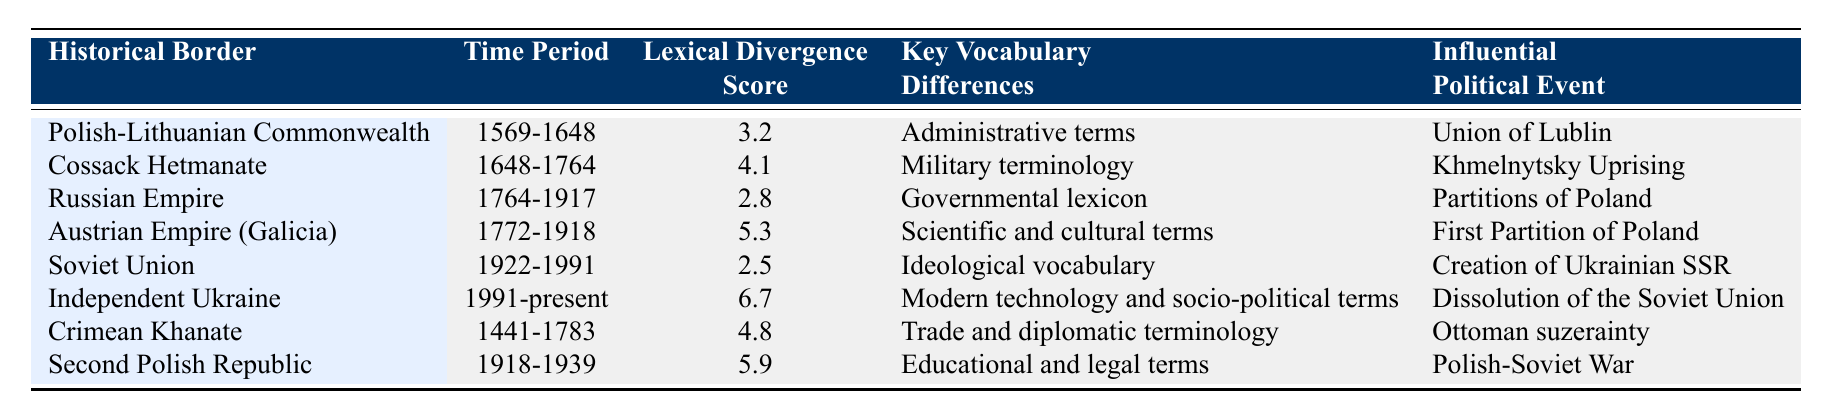What is the lexical divergence score for the Soviet Union? The table lists the lexical divergence score for the Soviet Union under the "Lexical Divergence Score" column, indicating it is 2.5.
Answer: 2.5 Which historical border had the highest lexical divergence score? By comparing the lexical divergence scores listed in the table, the highest score is 6.7, which corresponds to the Independent Ukraine.
Answer: 6.7 True or False: The Cossack Hetmanate period had a higher lexical divergence score than the Russian Empire period. The Cossack Hetmanate score is 4.1, while the Russian Empire score is 2.8. 4.1 is greater than 2.8, confirming the statement is true.
Answer: True Which time period corresponds to the lowest lexical divergence score? Scanning the table for the lowest score reveals the Soviet Union period from 1922-1991 with a score of 2.5.
Answer: Soviet Union (1922-1991) What is the difference between the highest and lowest lexical divergence scores in the table? The highest score is 6.7 (Independent Ukraine), and the lowest score is 2.5 (Soviet Union). To find the difference, we calculate 6.7 - 2.5 = 4.2.
Answer: 4.2 Which influential political event is associated with the highest lexical divergence score? The Independent Ukraine period has the highest score of 6.7, and it is associated with the influential political event "Dissolution of the Soviet Union."
Answer: Dissolution of the Soviet Union What key vocabulary differences do the Austrian Empire (Galicia) and the Second Polish Republic share? The Austrian Empire (Galicia) focuses on scientific and cultural terms, while the Second Polish Republic emphasizes educational and legal terms. These are distinctly different categories with no overlap noted.
Answer: No shared key vocabulary differences During which time period did the Crimean Khanate exist, and what was its lexical divergence score? The Crimean Khanate existed from 1441 to 1783, and the corresponding lexical divergence score is 4.8, as indicated in the table.
Answer: 4.8 (1441-1783) Which border influences have consistently led to higher lexical divergence scores, particularly during the periods of foreign dominion? Notable high scores arise from periods such as the Austrian Empire (5.3) and the Second Polish Republic (5.9), both indicating substantial divergence likely influenced by foreign rule.
Answer: Austrian Empire and Second Polish Republic 